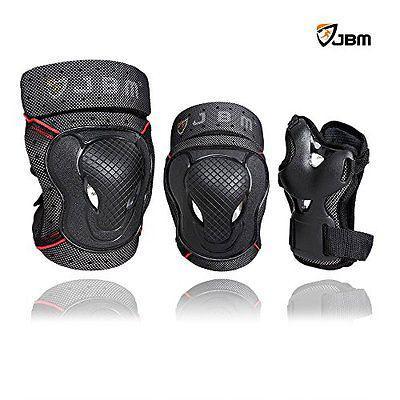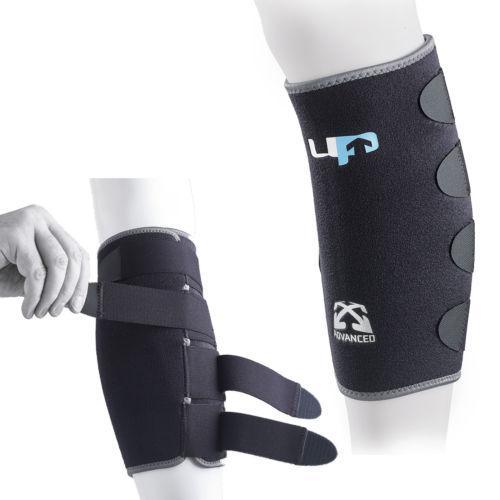The first image is the image on the left, the second image is the image on the right. Given the left and right images, does the statement "An image shows exactly three pads, which are not arranged in one horizontal row." hold true? Answer yes or no. No. The first image is the image on the left, the second image is the image on the right. Examine the images to the left and right. Is the description "There is a red marking on at least one of the knee pads in the image on the right side." accurate? Answer yes or no. No. 